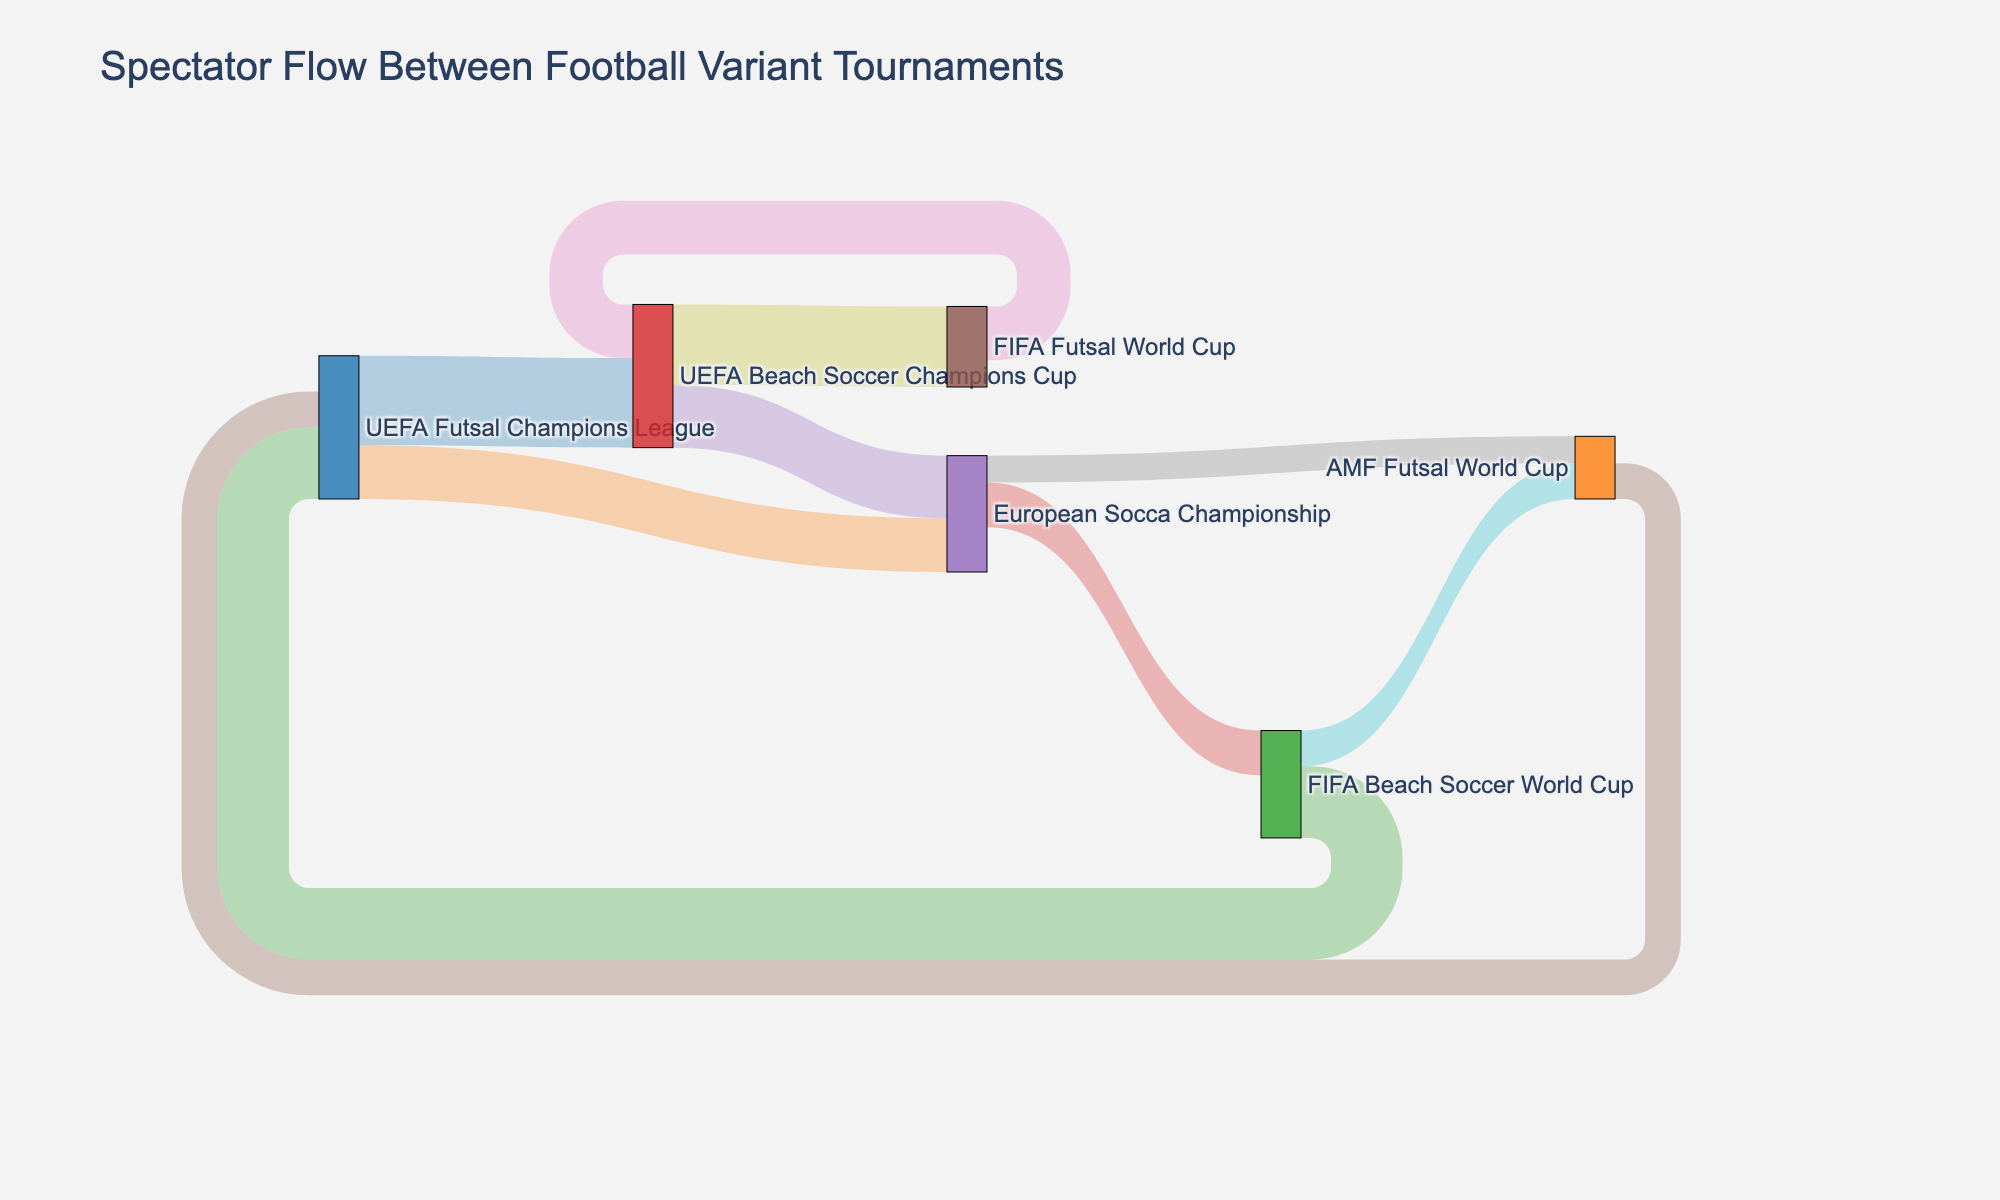What is the title of the Sankey Diagram? The title of the Sankey Diagram is found at the top of the figure. It provides a summary of what the diagram represents.
Answer: Spectator Flow Between Football Variant Tournaments How many different tournaments are depicted in the diagram? Count the unique labels in the nodes section of the Sankey Diagram, as each label represents a different tournament.
Answer: 7 Which tournament has the highest inflow of spectators? Look at the widths of the links targeting each tournament. The tournament with the widest connections targeting it will have the highest inflow.
Answer: UEFA Beach Soccer Champions Cup What is the total number of spectators flowing into the UEFA Futsal Champions League? Sum the values of all links ending at the UEFA Futsal Champions League from different source tournaments.
Answer: 6000 How does the spectator flow from the FIFA Futsal World Cup to the UEFA Beach Soccer Champions Cup compare to the flow from the European Socca Championship to the AMF Futsal World Cup? Compare the values of the links going from FIFA Futsal World Cup to UEFA Beach Soccer Champions Cup and from European Socca Championship to AMF Futsal World Cup.
Answer: FIFA Futsal World Cup to UEFA Beach Soccer Champions Cup is higher What is the largest spectator flow between any two tournaments? Identify the link with the highest value by comparing the values of all the links.
Answer: 4500 (UEFA Beach Soccer Champions Cup to FIFA Futsal World Cup) Which tournaments have spectators flowing into the European Socca Championship? Identify all source tournaments that have links targeting the European Socca Championship.
Answer: UEFA Futsal Champions League, UEFA Beach Soccer Champions Cup Compare the total outflow of spectators from the UEFA Futsal Champions League to the total outflow from the European Socca Championship. Sum the values of all links starting from the UEFA Futsal Champions League and compare with the sum of values of all links starting from the European Socca Championship.
Answer: UEFA Futsal Champions League has higher outflow What is the direction of spectator flow from the UEFA Beach Soccer Champions Cup? Identify the target tournaments where spectators from the UEFA Beach Soccer Champions Cup flow in the diagram.
Answer: UEFA Beach Soccer Champions Cup flows to European Socca Championship and to FIFA Futsal World Cup How many spectators flow from the European Socca Championship to the AMF Futsal World Cup? Find the value of the link connecting the European Socca Championship as the source and the AMF Futsal World Cup as the target.
Answer: 1500 